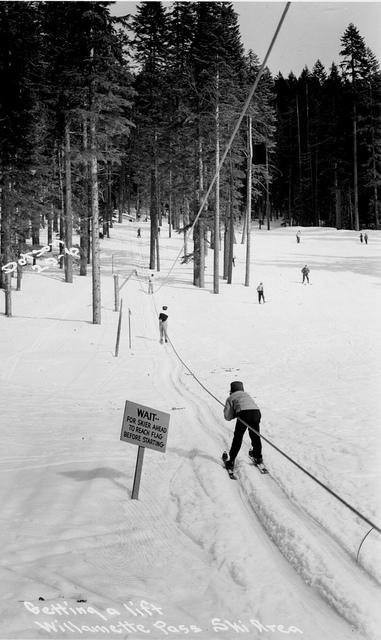Are these snowboarders?
Concise answer only. No. What are the people trying to do?
Answer briefly. Ski. What is she holding in her hands?
Give a very brief answer. Rope. What is the first word on the sign?
Keep it brief. Wait. 